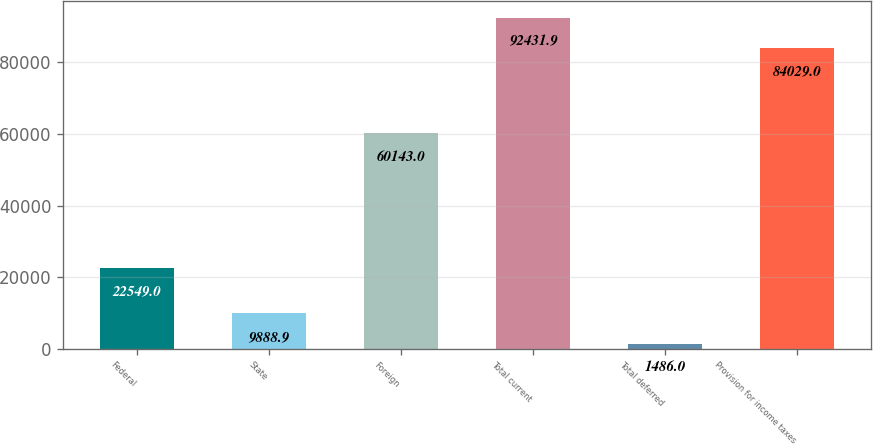Convert chart to OTSL. <chart><loc_0><loc_0><loc_500><loc_500><bar_chart><fcel>Federal<fcel>State<fcel>Foreign<fcel>Total current<fcel>Total deferred<fcel>Provision for income taxes<nl><fcel>22549<fcel>9888.9<fcel>60143<fcel>92431.9<fcel>1486<fcel>84029<nl></chart> 